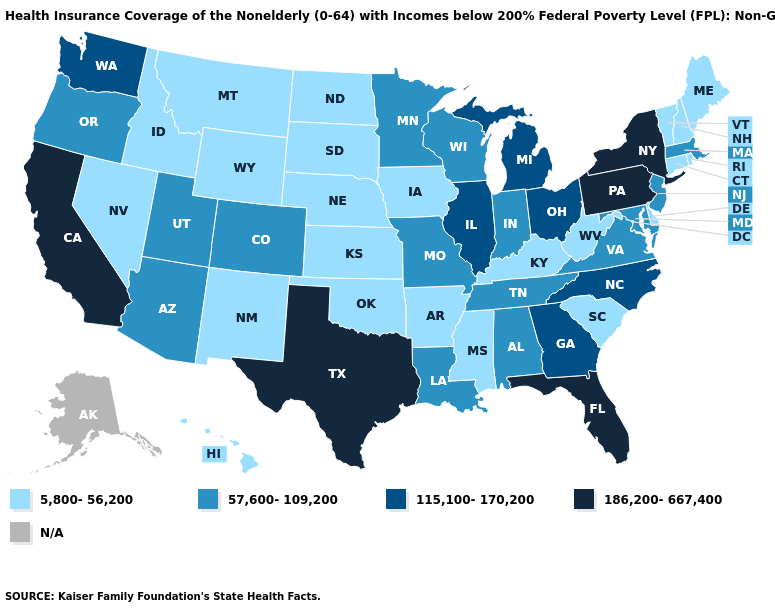Among the states that border Washington , does Idaho have the highest value?
Quick response, please. No. What is the value of Minnesota?
Give a very brief answer. 57,600-109,200. Name the states that have a value in the range 5,800-56,200?
Answer briefly. Arkansas, Connecticut, Delaware, Hawaii, Idaho, Iowa, Kansas, Kentucky, Maine, Mississippi, Montana, Nebraska, Nevada, New Hampshire, New Mexico, North Dakota, Oklahoma, Rhode Island, South Carolina, South Dakota, Vermont, West Virginia, Wyoming. Is the legend a continuous bar?
Write a very short answer. No. Does Texas have the highest value in the USA?
Give a very brief answer. Yes. Name the states that have a value in the range 186,200-667,400?
Give a very brief answer. California, Florida, New York, Pennsylvania, Texas. What is the value of Oregon?
Keep it brief. 57,600-109,200. Among the states that border Illinois , does Kentucky have the lowest value?
Quick response, please. Yes. What is the highest value in states that border Montana?
Answer briefly. 5,800-56,200. Among the states that border Wisconsin , which have the highest value?
Write a very short answer. Illinois, Michigan. Does the first symbol in the legend represent the smallest category?
Write a very short answer. Yes. Is the legend a continuous bar?
Short answer required. No. Does Wyoming have the lowest value in the West?
Be succinct. Yes. What is the value of Georgia?
Keep it brief. 115,100-170,200. 